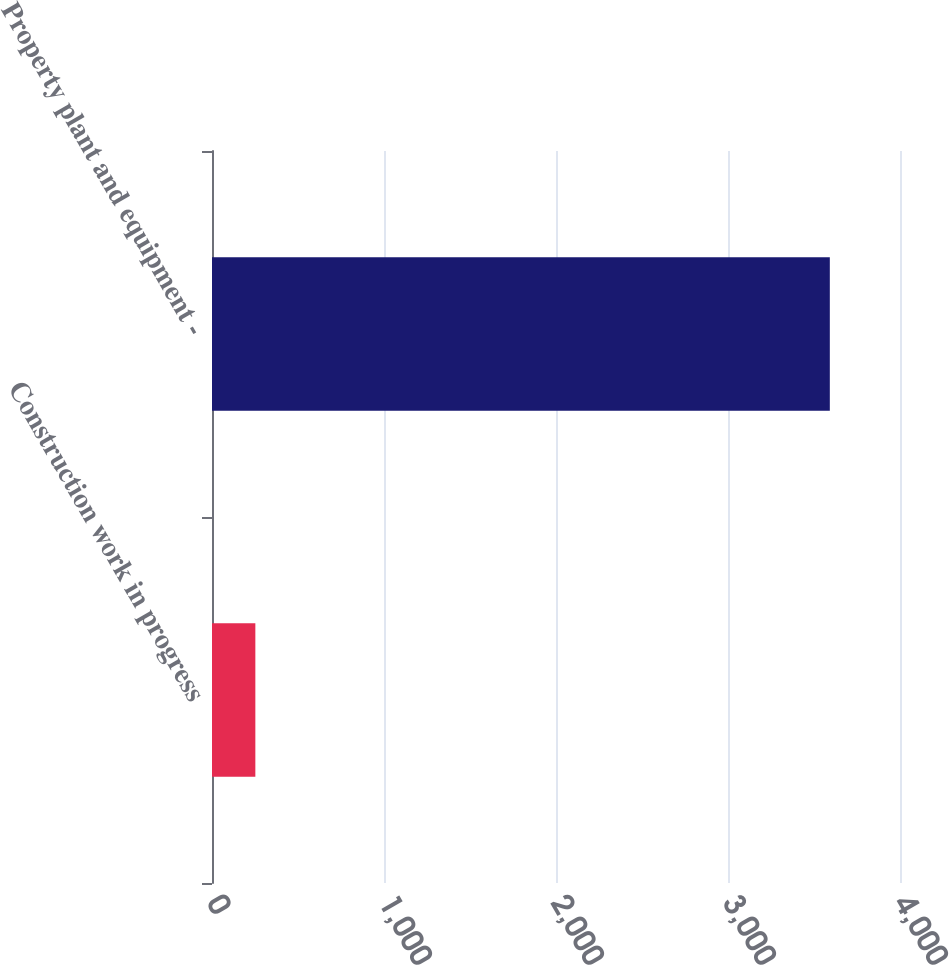Convert chart. <chart><loc_0><loc_0><loc_500><loc_500><bar_chart><fcel>Construction work in progress<fcel>Property plant and equipment -<nl><fcel>252<fcel>3592<nl></chart> 